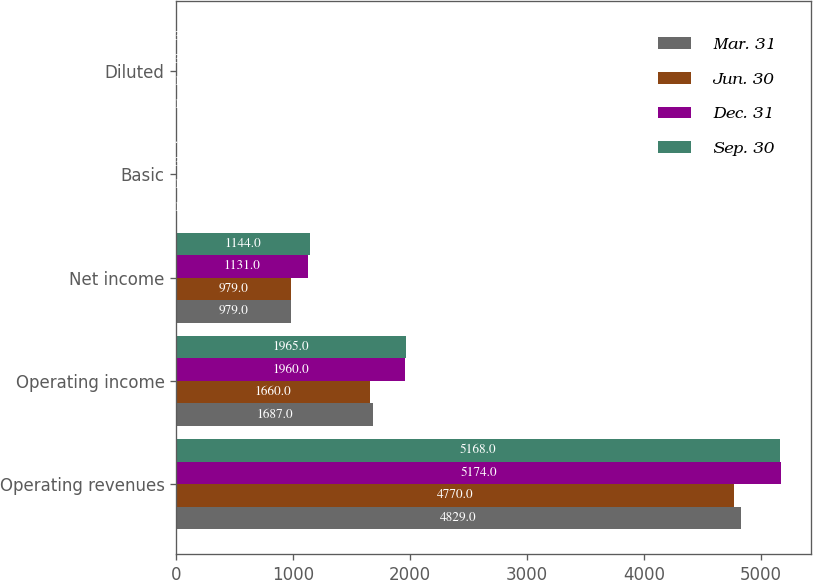Convert chart. <chart><loc_0><loc_0><loc_500><loc_500><stacked_bar_chart><ecel><fcel>Operating revenues<fcel>Operating income<fcel>Net income<fcel>Basic<fcel>Diluted<nl><fcel>Mar. 31<fcel>4829<fcel>1687<fcel>979<fcel>1.16<fcel>1.16<nl><fcel>Jun. 30<fcel>4770<fcel>1660<fcel>979<fcel>1.17<fcel>1.17<nl><fcel>Dec. 31<fcel>5174<fcel>1960<fcel>1131<fcel>1.36<fcel>1.36<nl><fcel>Sep. 30<fcel>5168<fcel>1965<fcel>1144<fcel>1.4<fcel>1.39<nl></chart> 